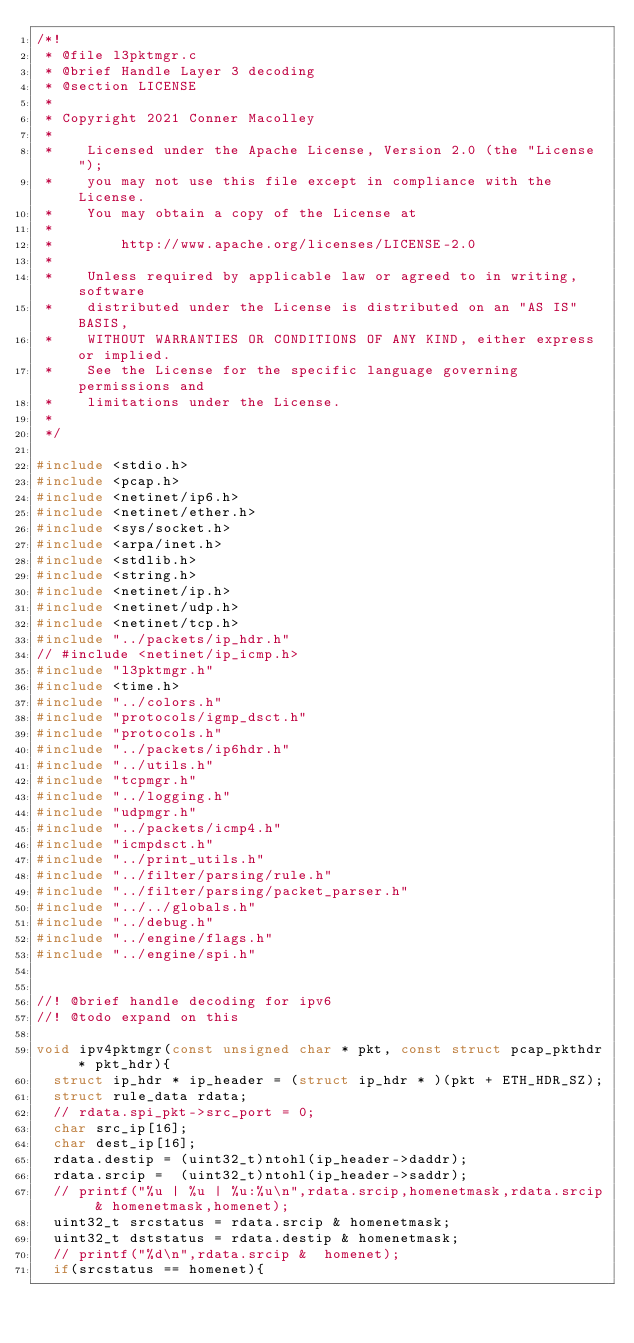Convert code to text. <code><loc_0><loc_0><loc_500><loc_500><_C_>/*!
 * @file l3pktmgr.c
 * @brief Handle Layer 3 decoding
 * @section LICENSE
 * 
 * Copyright 2021 Conner Macolley
 *
 *    Licensed under the Apache License, Version 2.0 (the "License");
 *    you may not use this file except in compliance with the License.
 *    You may obtain a copy of the License at
 *
 *        http://www.apache.org/licenses/LICENSE-2.0
 *
 *    Unless required by applicable law or agreed to in writing, software
 *    distributed under the License is distributed on an "AS IS" BASIS,
 *    WITHOUT WARRANTIES OR CONDITIONS OF ANY KIND, either express or implied.
 *    See the License for the specific language governing permissions and
 *    limitations under the License.
 *
 */

#include <stdio.h>
#include <pcap.h>
#include <netinet/ip6.h>
#include <netinet/ether.h>
#include <sys/socket.h>
#include <arpa/inet.h>
#include <stdlib.h>
#include <string.h>
#include <netinet/ip.h>
#include <netinet/udp.h>
#include <netinet/tcp.h>
#include "../packets/ip_hdr.h"
// #include <netinet/ip_icmp.h>
#include "l3pktmgr.h"
#include <time.h>
#include "../colors.h"
#include "protocols/igmp_dsct.h"
#include "protocols.h"
#include "../packets/ip6hdr.h"
#include "../utils.h"
#include "tcpmgr.h"
#include "../logging.h"
#include "udpmgr.h"
#include "../packets/icmp4.h"
#include "icmpdsct.h"
#include "../print_utils.h"
#include "../filter/parsing/rule.h"
#include "../filter/parsing/packet_parser.h"
#include "../../globals.h"
#include "../debug.h"
#include "../engine/flags.h"
#include "../engine/spi.h"


//! @brief handle decoding for ipv6
//! @todo expand on this

void ipv4pktmgr(const unsigned char * pkt, const struct pcap_pkthdr * pkt_hdr){
  struct ip_hdr * ip_header = (struct ip_hdr * )(pkt + ETH_HDR_SZ);
  struct rule_data rdata;
  // rdata.spi_pkt->src_port = 0;
  char src_ip[16];
  char dest_ip[16]; 
  rdata.destip = (uint32_t)ntohl(ip_header->daddr);
  rdata.srcip =  (uint32_t)ntohl(ip_header->saddr);
  // printf("%u | %u | %u:%u\n",rdata.srcip,homenetmask,rdata.srcip & homenetmask,homenet);
  uint32_t srcstatus = rdata.srcip & homenetmask;
  uint32_t dststatus = rdata.destip & homenetmask;
  // printf("%d\n",rdata.srcip &  homenet);
  if(srcstatus == homenet){</code> 